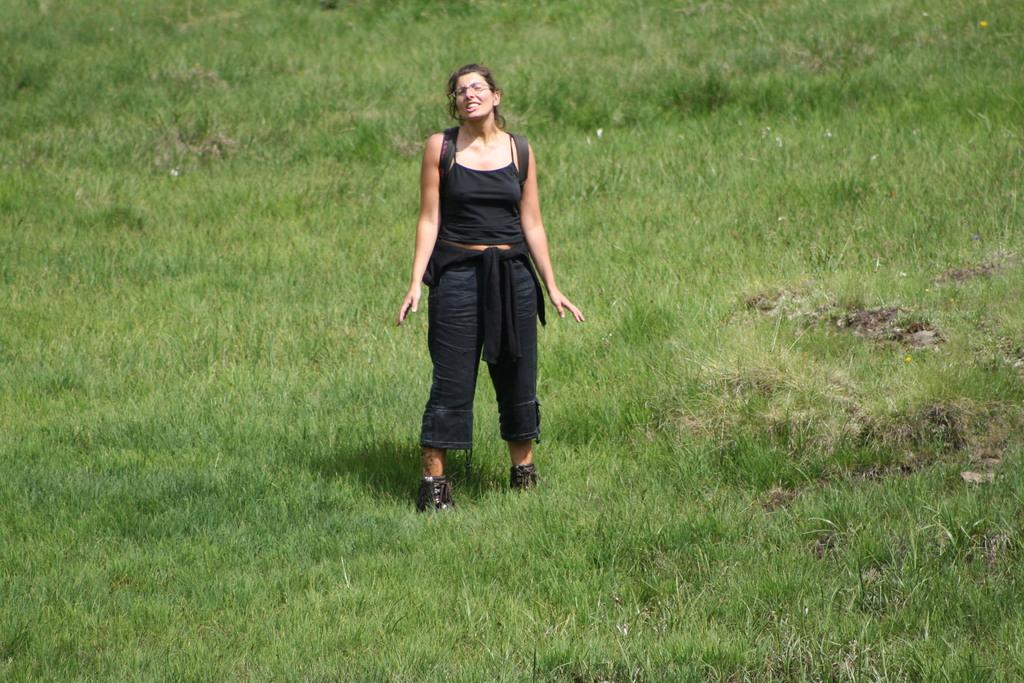What type of surface is visible on the ground in the image? There is grass on the ground in the image. Who is present in the image? There is a woman in the image. What is the woman wearing? The woman is wearing a black dress. What is the woman doing in the image? The woman is standing and giving a pose for the picture. What is the woman's facial expression in the image? The woman is smiling in the image. Can you see a boat in the image? No, there is no boat present in the image. What type of scissors is the woman using in the image? There are no scissors visible in the image. 